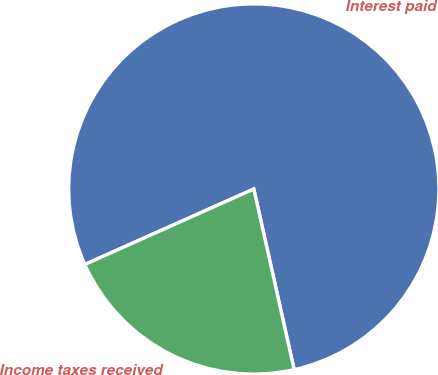Convert chart to OTSL. <chart><loc_0><loc_0><loc_500><loc_500><pie_chart><fcel>Interest paid<fcel>Income taxes received<nl><fcel>78.19%<fcel>21.81%<nl></chart> 